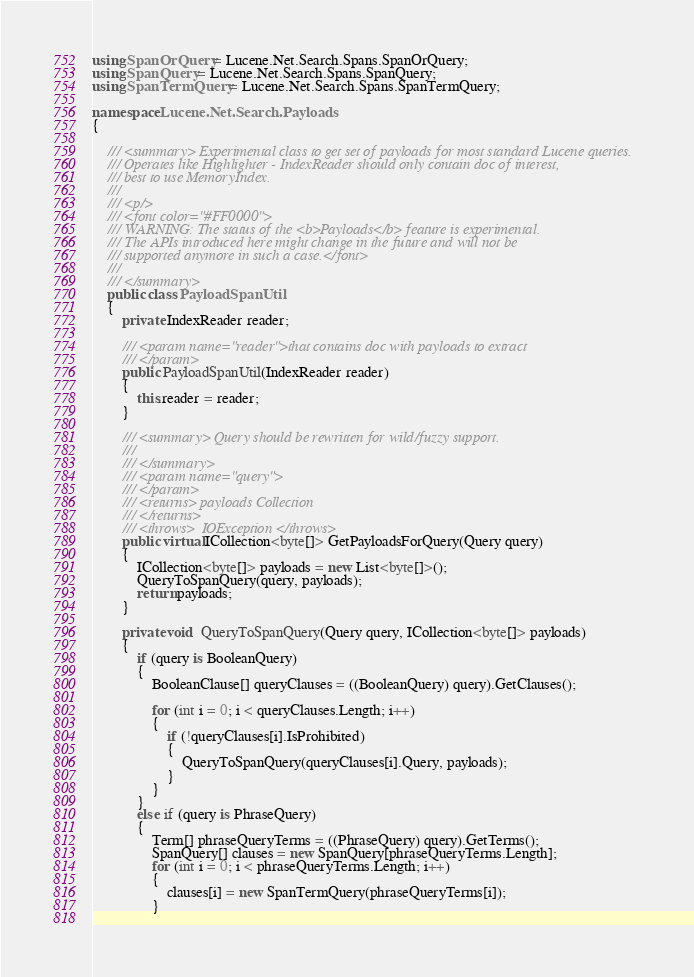Convert code to text. <code><loc_0><loc_0><loc_500><loc_500><_C#_>using SpanOrQuery = Lucene.Net.Search.Spans.SpanOrQuery;
using SpanQuery = Lucene.Net.Search.Spans.SpanQuery;
using SpanTermQuery = Lucene.Net.Search.Spans.SpanTermQuery;

namespace Lucene.Net.Search.Payloads
{
	
	/// <summary> Experimental class to get set of payloads for most standard Lucene queries.
	/// Operates like Highlighter - IndexReader should only contain doc of interest,
	/// best to use MemoryIndex.
	/// 
	/// <p/>
	/// <font color="#FF0000">
	/// WARNING: The status of the <b>Payloads</b> feature is experimental.
	/// The APIs introduced here might change in the future and will not be
	/// supported anymore in such a case.</font>
	/// 
	/// </summary>
	public class PayloadSpanUtil
	{
		private IndexReader reader;
		
		/// <param name="reader">that contains doc with payloads to extract
		/// </param>
		public PayloadSpanUtil(IndexReader reader)
		{
			this.reader = reader;
		}
		
		/// <summary> Query should be rewritten for wild/fuzzy support.
		/// 
		/// </summary>
		/// <param name="query">
		/// </param>
		/// <returns> payloads Collection
		/// </returns>
		/// <throws>  IOException </throws>
		public virtual ICollection<byte[]> GetPayloadsForQuery(Query query)
		{
			ICollection<byte[]> payloads = new List<byte[]>();
			QueryToSpanQuery(query, payloads);
			return payloads;
		}
		
		private void  QueryToSpanQuery(Query query, ICollection<byte[]> payloads)
		{
			if (query is BooleanQuery)
			{
				BooleanClause[] queryClauses = ((BooleanQuery) query).GetClauses();
				
				for (int i = 0; i < queryClauses.Length; i++)
				{
                    if (!queryClauses[i].IsProhibited)
					{
						QueryToSpanQuery(queryClauses[i].Query, payloads);
					}
				}
			}
			else if (query is PhraseQuery)
			{
				Term[] phraseQueryTerms = ((PhraseQuery) query).GetTerms();
				SpanQuery[] clauses = new SpanQuery[phraseQueryTerms.Length];
				for (int i = 0; i < phraseQueryTerms.Length; i++)
				{
					clauses[i] = new SpanTermQuery(phraseQueryTerms[i]);
				}
				</code> 